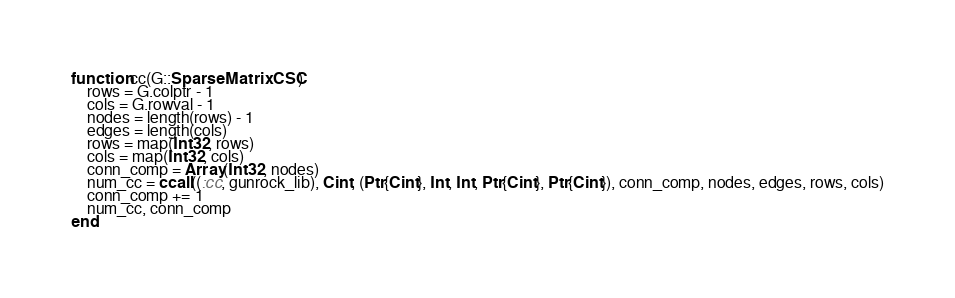Convert code to text. <code><loc_0><loc_0><loc_500><loc_500><_Julia_>function cc(G::SparseMatrixCSC)
	rows = G.colptr - 1
    cols = G.rowval - 1
    nodes = length(rows) - 1
    edges = length(cols)
    rows = map(Int32, rows)
    cols = map(Int32, cols)
    conn_comp = Array(Int32, nodes)
	num_cc = ccall((:cc, gunrock_lib), Cint, (Ptr{Cint}, Int, Int, Ptr{Cint}, Ptr{Cint}), conn_comp, nodes, edges, rows, cols)
    conn_comp += 1
	num_cc, conn_comp
end
</code> 